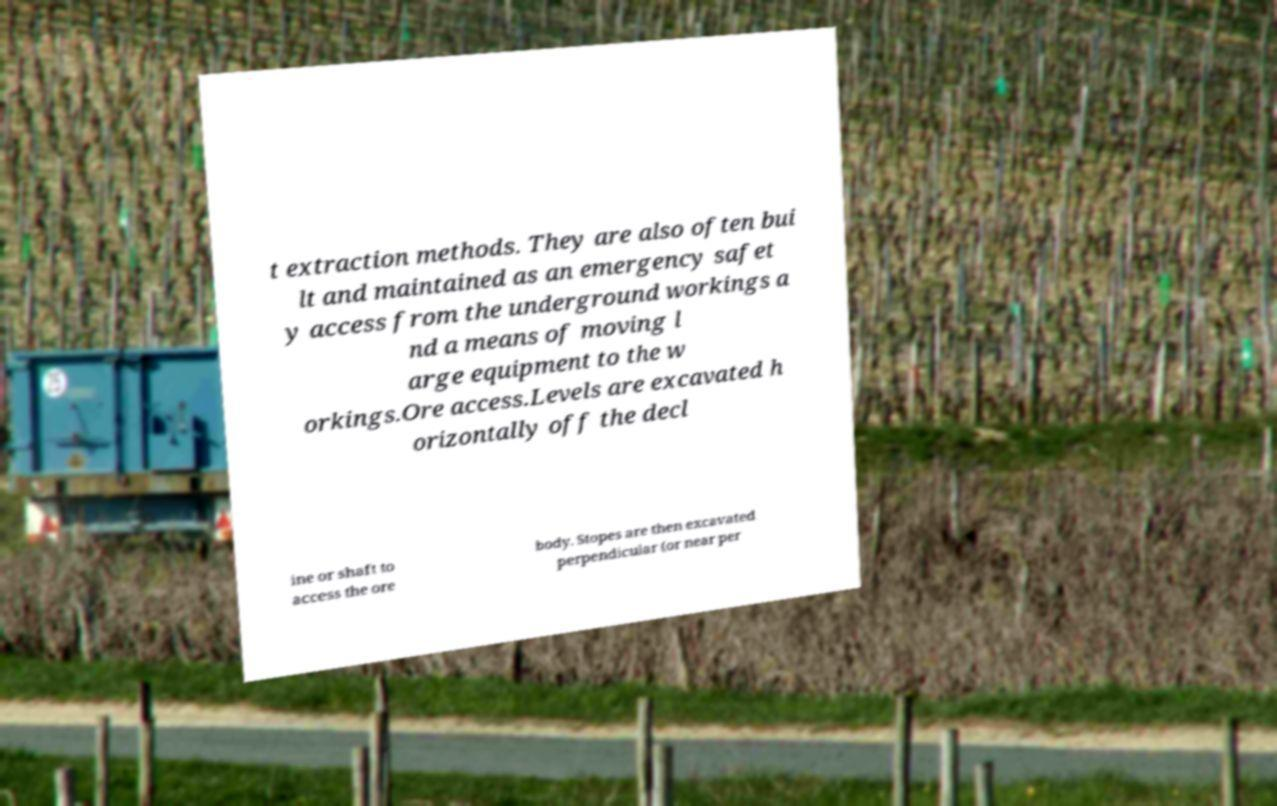There's text embedded in this image that I need extracted. Can you transcribe it verbatim? t extraction methods. They are also often bui lt and maintained as an emergency safet y access from the underground workings a nd a means of moving l arge equipment to the w orkings.Ore access.Levels are excavated h orizontally off the decl ine or shaft to access the ore body. Stopes are then excavated perpendicular (or near per 